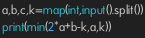<code> <loc_0><loc_0><loc_500><loc_500><_Python_>a,b,c,k=map(int,input().split())
print(min(2*a+b-k,a,k))</code> 